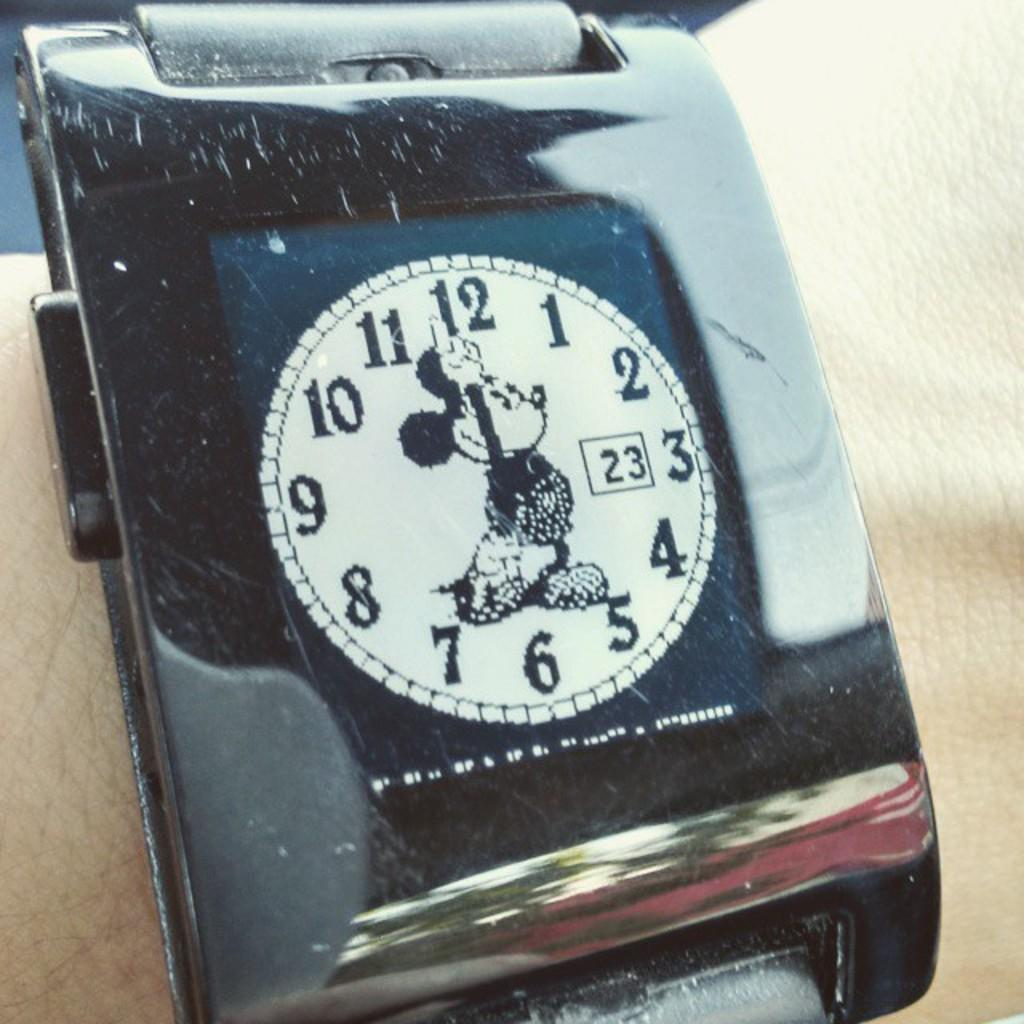<image>
Create a compact narrative representing the image presented. A mickey mouse watch with the date as the 23rd. 